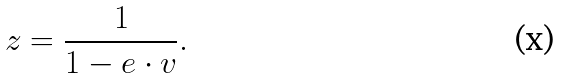Convert formula to latex. <formula><loc_0><loc_0><loc_500><loc_500>z = \frac { 1 } { 1 - e \cdot v } .</formula> 